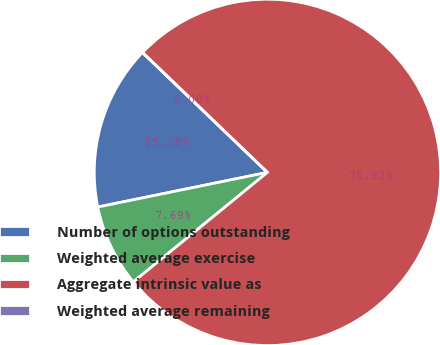Convert chart to OTSL. <chart><loc_0><loc_0><loc_500><loc_500><pie_chart><fcel>Number of options outstanding<fcel>Weighted average exercise<fcel>Aggregate intrinsic value as<fcel>Weighted average remaining<nl><fcel>15.38%<fcel>7.69%<fcel>76.92%<fcel>0.0%<nl></chart> 